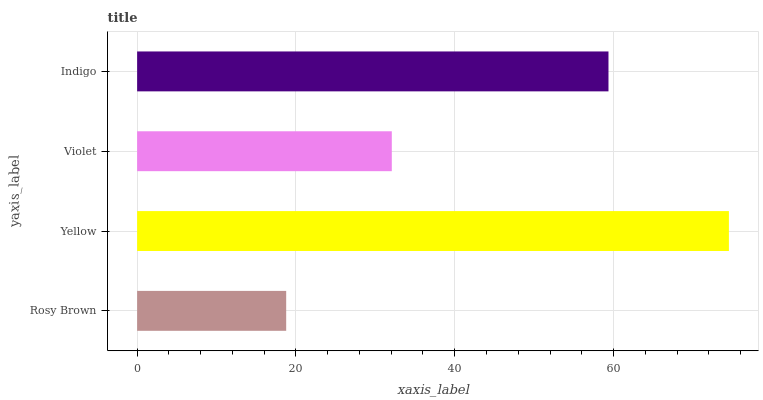Is Rosy Brown the minimum?
Answer yes or no. Yes. Is Yellow the maximum?
Answer yes or no. Yes. Is Violet the minimum?
Answer yes or no. No. Is Violet the maximum?
Answer yes or no. No. Is Yellow greater than Violet?
Answer yes or no. Yes. Is Violet less than Yellow?
Answer yes or no. Yes. Is Violet greater than Yellow?
Answer yes or no. No. Is Yellow less than Violet?
Answer yes or no. No. Is Indigo the high median?
Answer yes or no. Yes. Is Violet the low median?
Answer yes or no. Yes. Is Yellow the high median?
Answer yes or no. No. Is Indigo the low median?
Answer yes or no. No. 